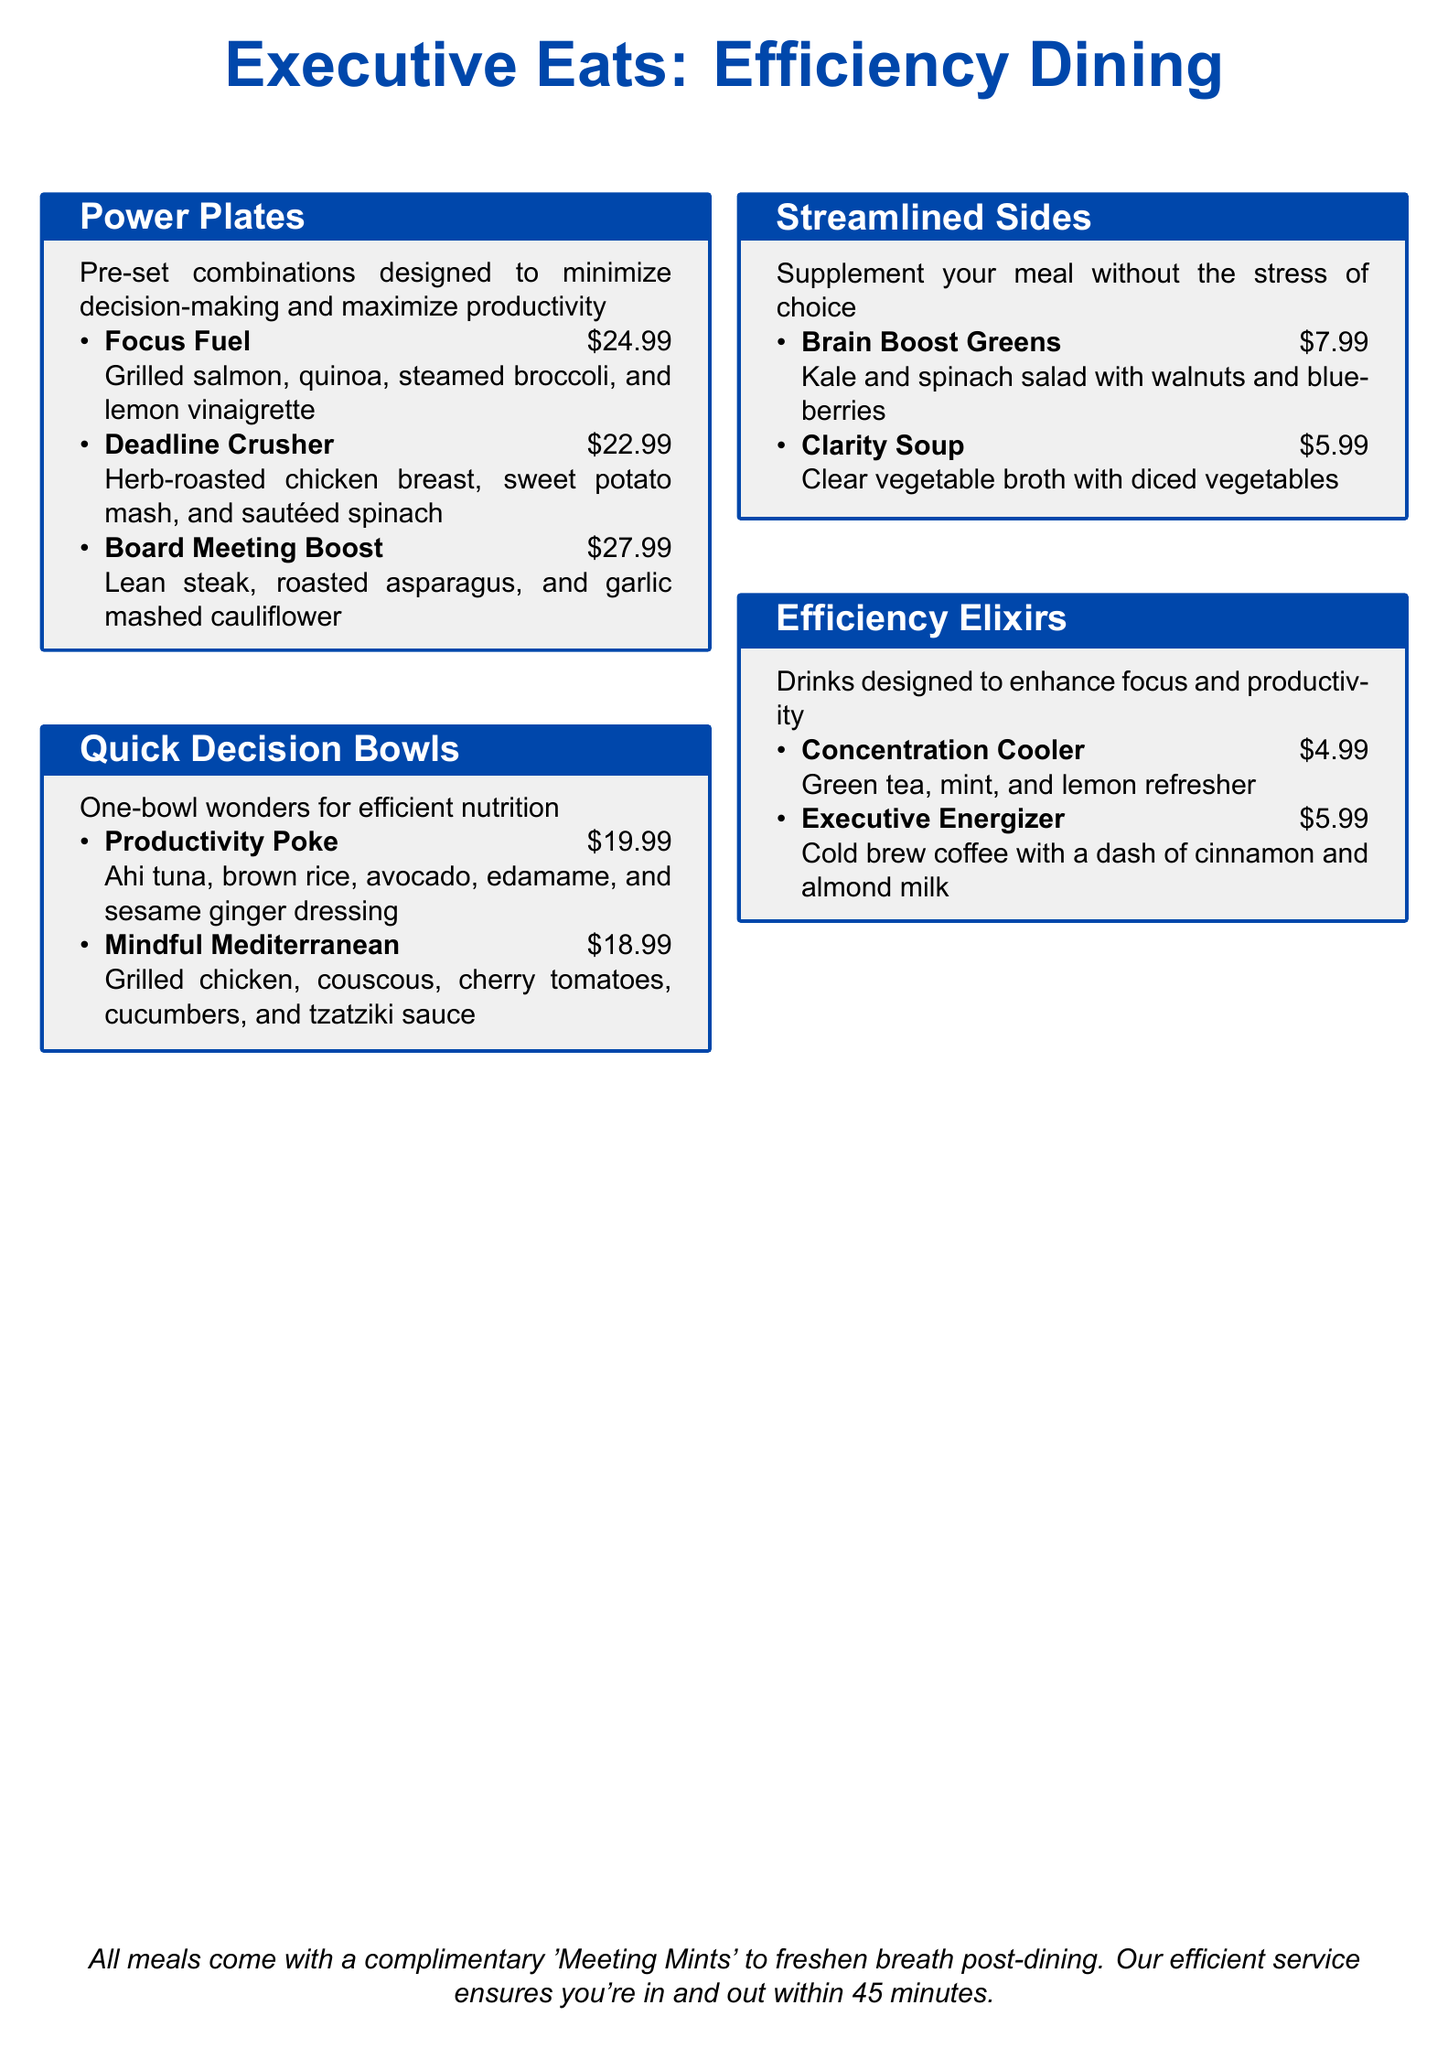What is the price of the Focus Fuel meal? The price of the Focus Fuel meal is listed in the Power Plates section, which is $24.99.
Answer: $24.99 What is included in the Board Meeting Boost? The Board Meeting Boost includes lean steak, roasted asparagus, and garlic mashed cauliflower, which are all mentioned in the Power Plates section.
Answer: Lean steak, roasted asparagus, and garlic mashed cauliflower Which drink is priced at $4.99? The drink priced at $4.99 is mentioned in the Efficiency Elixirs section and is called the Concentration Cooler.
Answer: Concentration Cooler What are the components of the Mindful Mediterranean bowl? The Mindful Mediterranean bowl consists of grilled chicken, couscous, cherry tomatoes, cucumbers, and tzatziki sauce, as detailed in the Quick Decision Bowls section.
Answer: Grilled chicken, couscous, cherry tomatoes, cucumbers, and tzatziki sauce What is the cost of the Clarity Soup? The cost of the Clarity Soup is listed under the Streamlined Sides section, which is $5.99.
Answer: $5.99 How many minutes does the service aim to take? The document states that the efficient service ensures you're in and out within 45 minutes, which is explicitly mentioned at the bottom of the menu.
Answer: 45 minutes Which meal is named after a productivity concept? The meal named after a productivity concept is the Deadline Crusher, which reflects a focus on helping customers stay productive, as noted in the Power Plates section.
Answer: Deadline Crusher What type of salad is the Brain Boost Greens? The Brain Boost Greens salad is described as a kale and spinach salad with walnuts and blueberries in the Streamlined Sides section.
Answer: Kale and spinach salad with walnuts and blueberries 